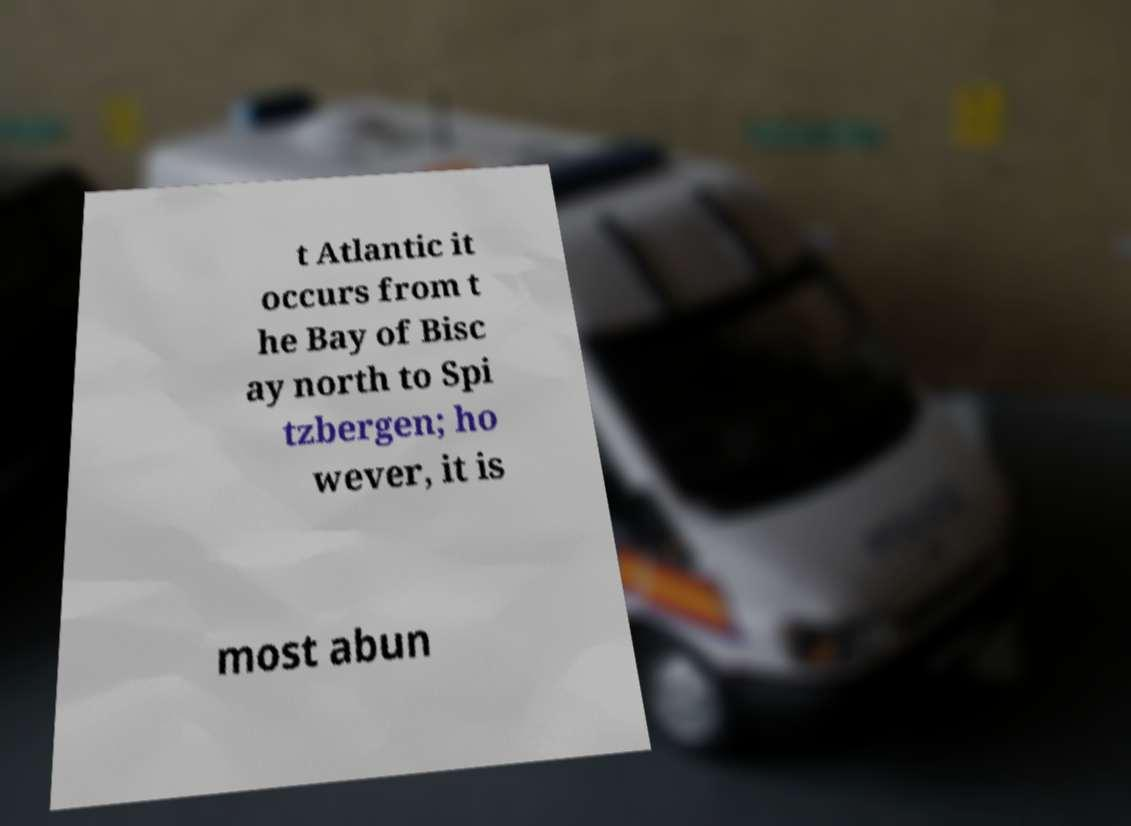Please identify and transcribe the text found in this image. t Atlantic it occurs from t he Bay of Bisc ay north to Spi tzbergen; ho wever, it is most abun 